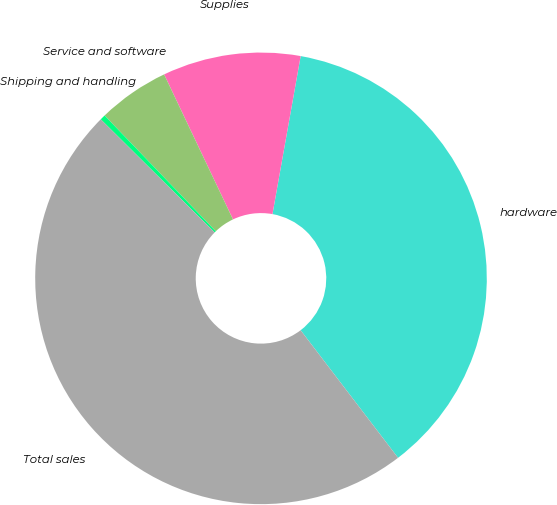Convert chart to OTSL. <chart><loc_0><loc_0><loc_500><loc_500><pie_chart><fcel>hardware<fcel>Supplies<fcel>Service and software<fcel>Shipping and handling<fcel>Total sales<nl><fcel>36.81%<fcel>9.87%<fcel>5.12%<fcel>0.38%<fcel>47.82%<nl></chart> 